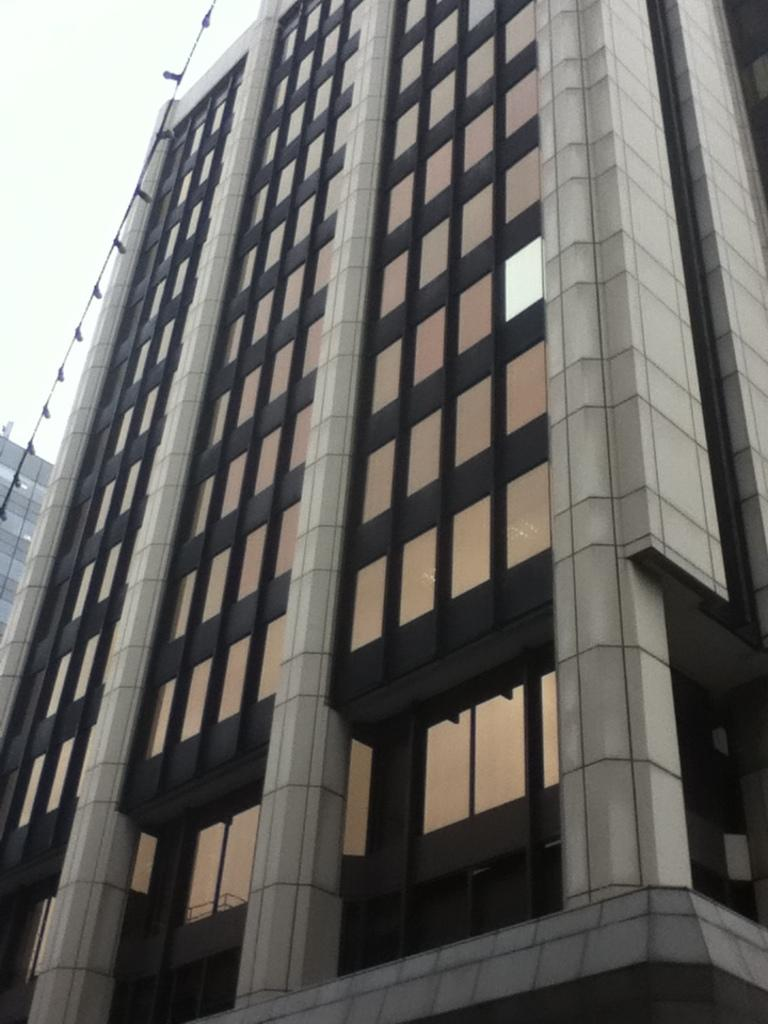What type of structures can be seen in the image? There are buildings in the image. What else is present in the image besides the buildings? There is a wire with objects in the image. What part of the natural environment is visible in the image? The sky is visible in the image. Can you read the receipt that is visible in the image? There is no receipt present in the image. Is there snow falling in the image? There is no snow visible in the image. 